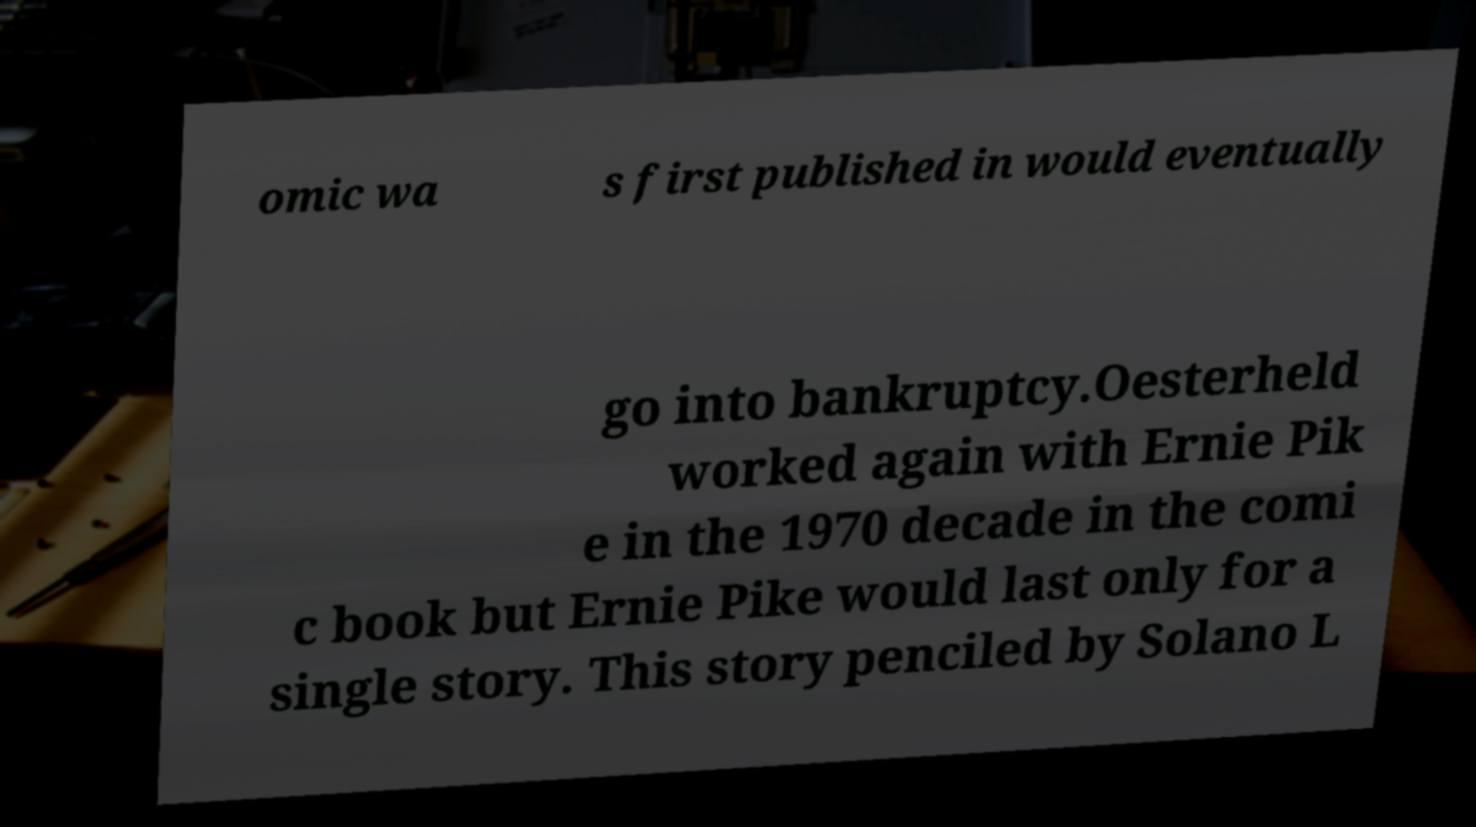What messages or text are displayed in this image? I need them in a readable, typed format. omic wa s first published in would eventually go into bankruptcy.Oesterheld worked again with Ernie Pik e in the 1970 decade in the comi c book but Ernie Pike would last only for a single story. This story penciled by Solano L 